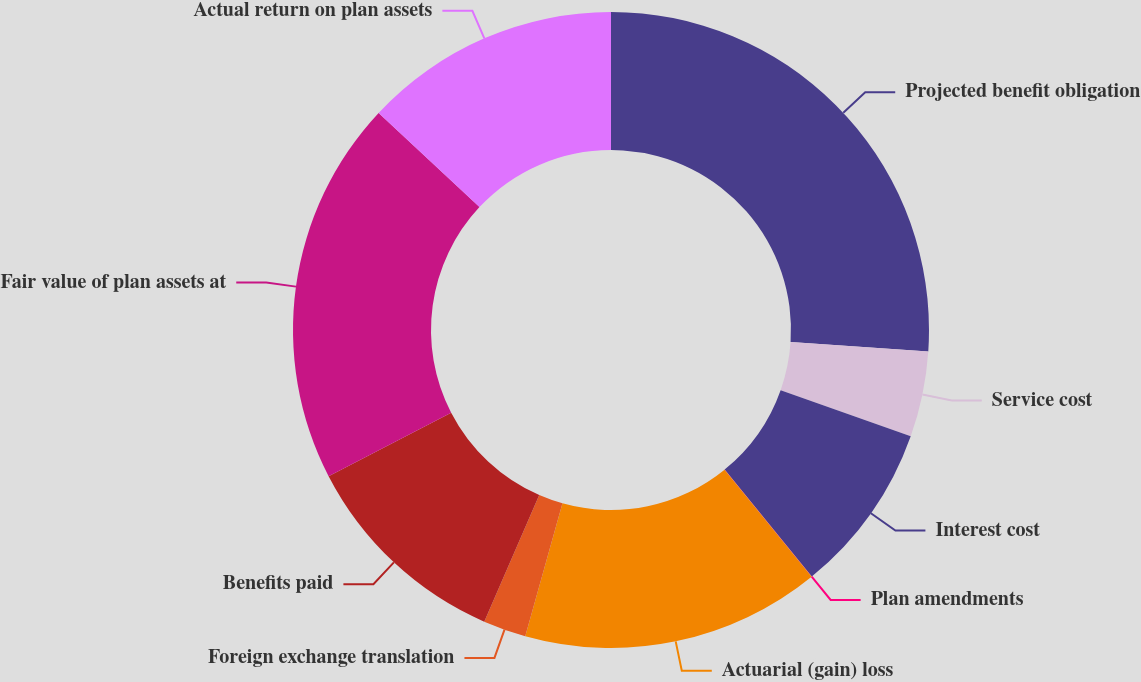<chart> <loc_0><loc_0><loc_500><loc_500><pie_chart><fcel>Projected benefit obligation<fcel>Service cost<fcel>Interest cost<fcel>Plan amendments<fcel>Actuarial (gain) loss<fcel>Foreign exchange translation<fcel>Benefits paid<fcel>Fair value of plan assets at<fcel>Actual return on plan assets<nl><fcel>26.07%<fcel>4.35%<fcel>8.7%<fcel>0.01%<fcel>15.21%<fcel>2.18%<fcel>10.87%<fcel>19.56%<fcel>13.04%<nl></chart> 